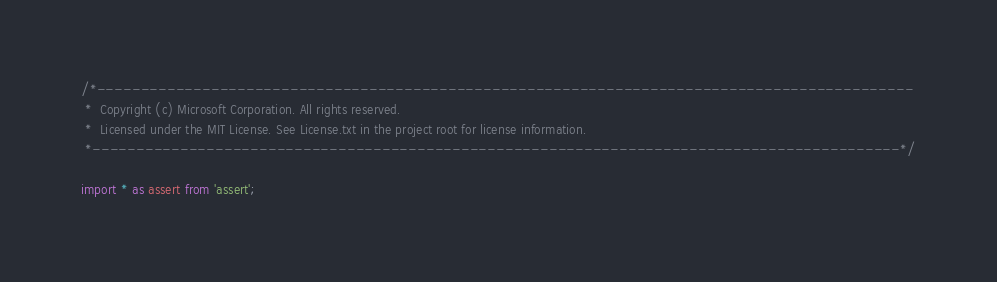<code> <loc_0><loc_0><loc_500><loc_500><_TypeScript_>/*---------------------------------------------------------------------------------------------
 *  Copyright (c) Microsoft Corporation. All rights reserved.
 *  Licensed under the MIT License. See License.txt in the project root for license information.
 *--------------------------------------------------------------------------------------------*/

import * as assert from 'assert';</code> 